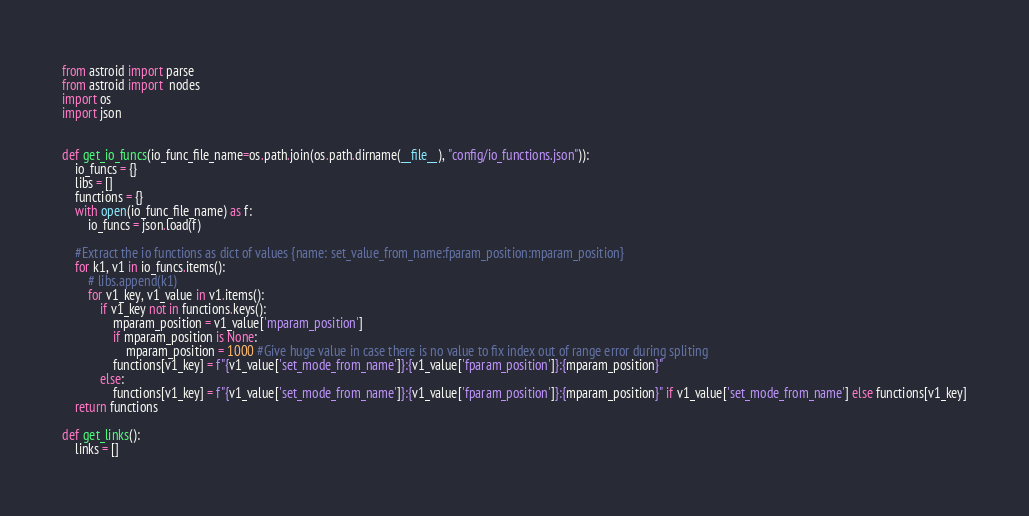Convert code to text. <code><loc_0><loc_0><loc_500><loc_500><_Python_>from astroid import parse
from astroid import  nodes
import os
import json


def get_io_funcs(io_func_file_name=os.path.join(os.path.dirname(__file__), "config/io_functions.json")):
    io_funcs = {}
    libs = []
    functions = {}
    with open(io_func_file_name) as f:
        io_funcs = json.load(f)
    
    #Extract the io functions as dict of values {name: set_value_from_name:fparam_position:mparam_position}
    for k1, v1 in io_funcs.items():
        # libs.append(k1)
        for v1_key, v1_value in v1.items():
            if v1_key not in functions.keys():
                mparam_position = v1_value['mparam_position']
                if mparam_position is None:
                    mparam_position = 1000 #Give huge value in case there is no value to fix index out of range error during spliting
                functions[v1_key] = f"{v1_value['set_mode_from_name']}:{v1_value['fparam_position']}:{mparam_position}"
            else:
                functions[v1_key] = f"{v1_value['set_mode_from_name']}:{v1_value['fparam_position']}:{mparam_position}" if v1_value['set_mode_from_name'] else functions[v1_key]
    return functions

def get_links():
    links = []




</code> 